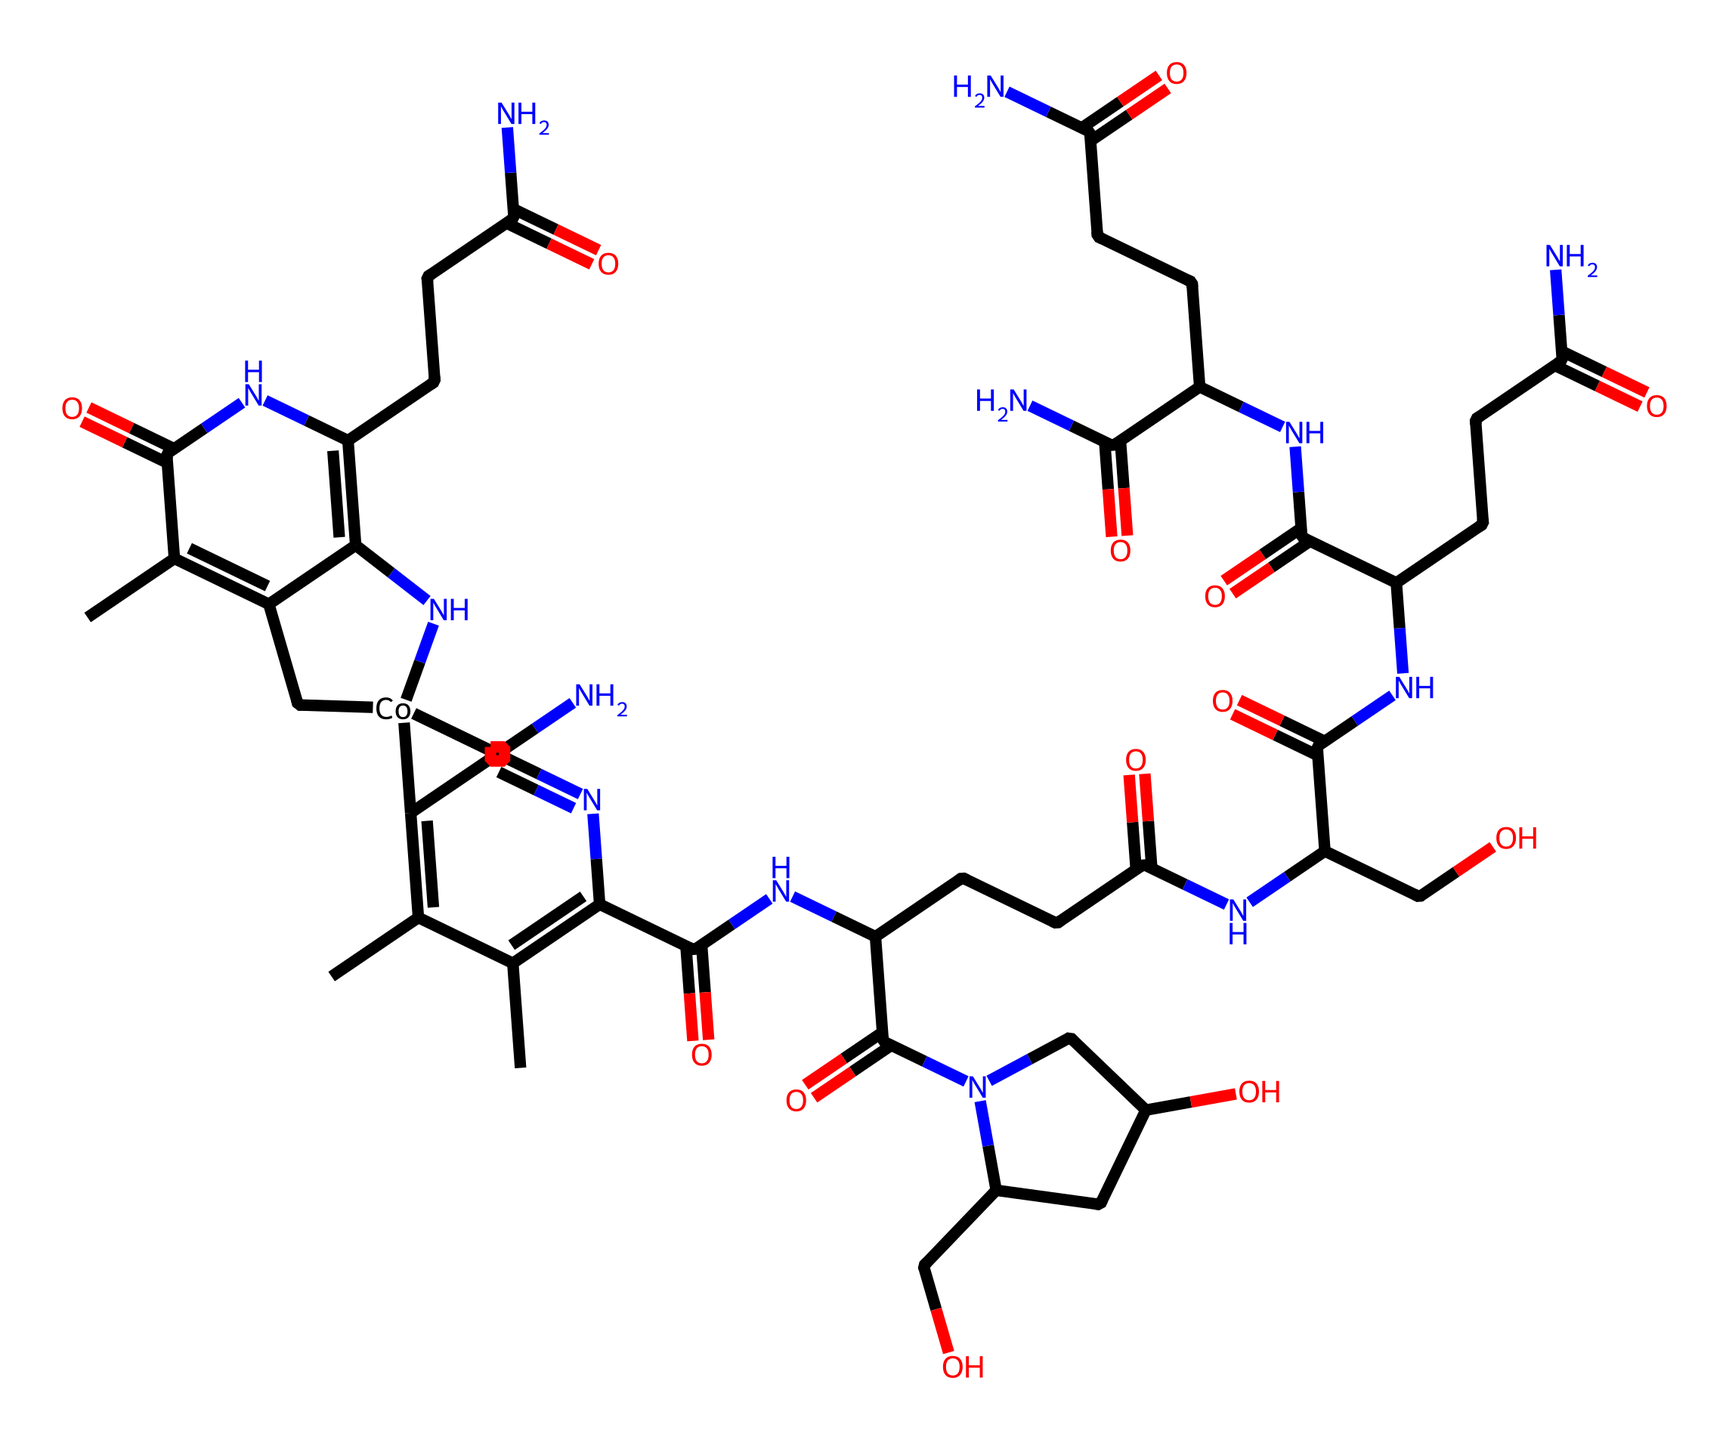What is the molecular formula of vitamin B12 based on this structure? By analyzing the SMILES representation, we can determine the molecular formula. Each type of atom (carbon, nitrogen, oxygen, cobalt) in the structure is counted: Carbon (C) = 73, Nitrogen (N) = 13, Oxygen (O) = 17, Cobalt (Co) = 1. Therefore, the molecular formula is C73H99CoN13O17.
Answer: C73H99CoN13O17 How many rings are present in the molecular structure of vitamin B12? In the SMILES representation, we identify the rings by looking for numbers indicating bond connections forming cycles. There are several ring numbers throughout the structure (1-5), indicating that there are 5 rings in total.
Answer: 5 What role does cobalt play in the structure of vitamin B12? Cobalt is a metal ion that is central to vitamin B12's structure. It acts as a cofactor in enzymatic reactions. In the SMILES representation, cobalt is the central atom firmly established in the structure's core, essential for the function of vitamin B12.
Answer: cofactor What is the significance of amino acids represented in the structure of vitamin B12? The presence of the amide (–C(=O)N–) linkages indicates that there are amino acid components in vitamin B12, which are crucial for its function in the body, particularly in processes like DNA synthesis and cognitive function.
Answer: crucial for function Which part of vitamin B12 is responsible for its activity in cognitive function? The central cobalt ion, incorporated within a corrin ring structure, is vital for vitamin B12’s bioactivity. This arrangement allows the molecule to participate in neurological processes, impacting cognitive function through cellular metabolism.
Answer: cobalt ion 